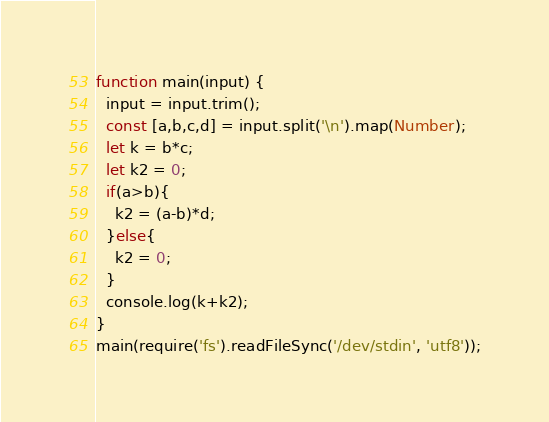Convert code to text. <code><loc_0><loc_0><loc_500><loc_500><_JavaScript_>function main(input) {
  input = input.trim();
  const [a,b,c,d] = input.split('\n').map(Number);
  let k = b*c;
  let k2 = 0;
  if(a>b){
    k2 = (a-b)*d;
  }else{
    k2 = 0;
  }
  console.log(k+k2);
}
main(require('fs').readFileSync('/dev/stdin', 'utf8'));</code> 